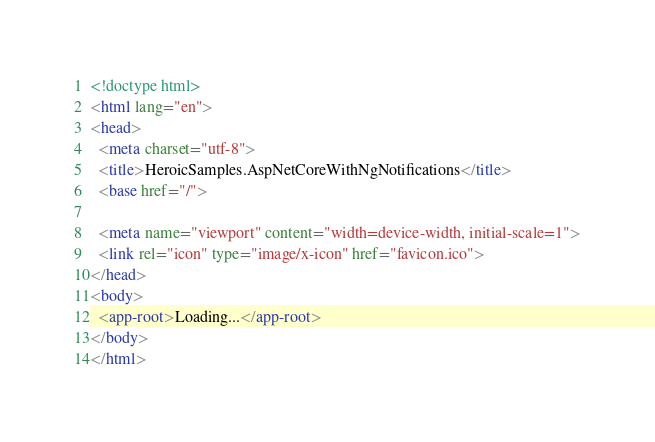Convert code to text. <code><loc_0><loc_0><loc_500><loc_500><_HTML_><!doctype html>
<html lang="en">
<head>
  <meta charset="utf-8">
  <title>HeroicSamples.AspNetCoreWithNgNotifications</title>
  <base href="/">

  <meta name="viewport" content="width=device-width, initial-scale=1">
  <link rel="icon" type="image/x-icon" href="favicon.ico">
</head>
<body>
  <app-root>Loading...</app-root>
</body>
</html>
</code> 